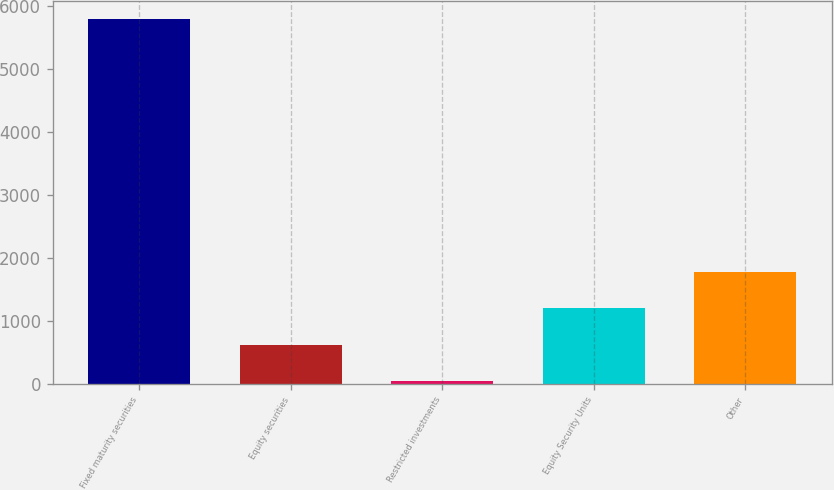Convert chart. <chart><loc_0><loc_0><loc_500><loc_500><bar_chart><fcel>Fixed maturity securities<fcel>Equity securities<fcel>Restricted investments<fcel>Equity Security Units<fcel>Other<nl><fcel>5797.4<fcel>623.3<fcel>48.4<fcel>1198.2<fcel>1773.1<nl></chart> 